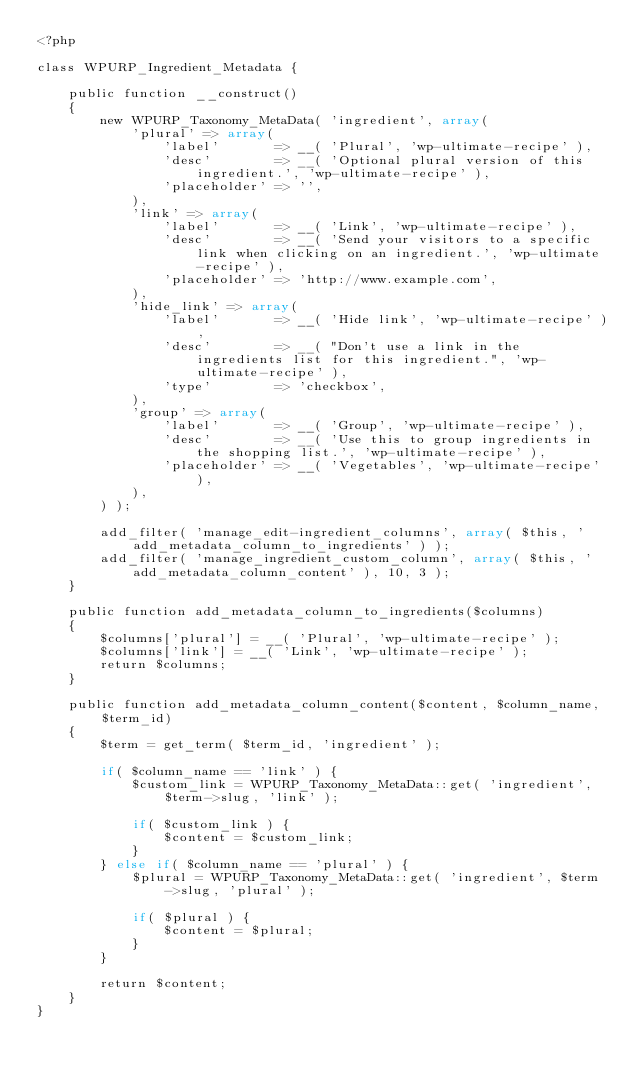<code> <loc_0><loc_0><loc_500><loc_500><_PHP_><?php

class WPURP_Ingredient_Metadata {

    public function __construct()
    {
        new WPURP_Taxonomy_MetaData( 'ingredient', array(
            'plural' => array(
                'label'       => __( 'Plural', 'wp-ultimate-recipe' ),
                'desc'        => __( 'Optional plural version of this ingredient.', 'wp-ultimate-recipe' ),
                'placeholder' => '',
            ),
            'link' => array(
                'label'       => __( 'Link', 'wp-ultimate-recipe' ),
                'desc'        => __( 'Send your visitors to a specific link when clicking on an ingredient.', 'wp-ultimate-recipe' ),
                'placeholder' => 'http://www.example.com',
            ),
            'hide_link' => array(
                'label'       => __( 'Hide link', 'wp-ultimate-recipe' ),
                'desc'        => __( "Don't use a link in the ingredients list for this ingredient.", 'wp-ultimate-recipe' ),
                'type'        => 'checkbox',
            ),
            'group' => array(
                'label'       => __( 'Group', 'wp-ultimate-recipe' ),
                'desc'        => __( 'Use this to group ingredients in the shopping list.', 'wp-ultimate-recipe' ),
                'placeholder' => __( 'Vegetables', 'wp-ultimate-recipe' ),
            ),
        ) );

        add_filter( 'manage_edit-ingredient_columns', array( $this, 'add_metadata_column_to_ingredients' ) );
        add_filter( 'manage_ingredient_custom_column', array( $this, 'add_metadata_column_content' ), 10, 3 );
    }

    public function add_metadata_column_to_ingredients($columns)
    {
        $columns['plural'] = __( 'Plural', 'wp-ultimate-recipe' );
        $columns['link'] = __( 'Link', 'wp-ultimate-recipe' );
        return $columns;
    }

    public function add_metadata_column_content($content, $column_name, $term_id)
    {
        $term = get_term( $term_id, 'ingredient' );

        if( $column_name == 'link' ) {
            $custom_link = WPURP_Taxonomy_MetaData::get( 'ingredient', $term->slug, 'link' );

            if( $custom_link ) {
                $content = $custom_link;
            }
        } else if( $column_name == 'plural' ) {
            $plural = WPURP_Taxonomy_MetaData::get( 'ingredient', $term->slug, 'plural' );

            if( $plural ) {
                $content = $plural;
            }
        }

        return $content;
    }
}</code> 